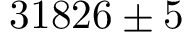<formula> <loc_0><loc_0><loc_500><loc_500>3 1 8 2 6 \pm 5</formula> 